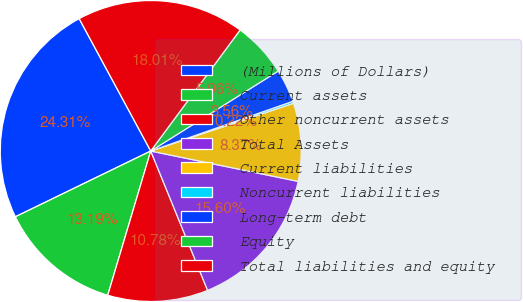Convert chart. <chart><loc_0><loc_0><loc_500><loc_500><pie_chart><fcel>(Millions of Dollars)<fcel>Current assets<fcel>Other noncurrent assets<fcel>Total Assets<fcel>Current liabilities<fcel>Noncurrent liabilities<fcel>Long-term debt<fcel>Equity<fcel>Total liabilities and equity<nl><fcel>24.31%<fcel>13.19%<fcel>10.78%<fcel>15.6%<fcel>8.37%<fcel>0.22%<fcel>3.56%<fcel>5.96%<fcel>18.01%<nl></chart> 